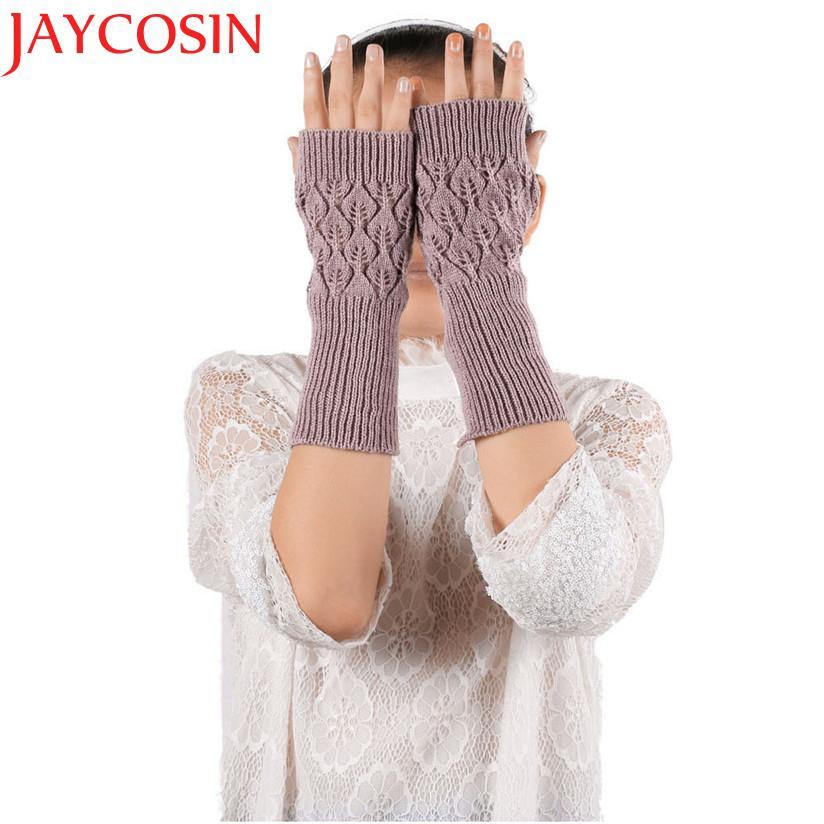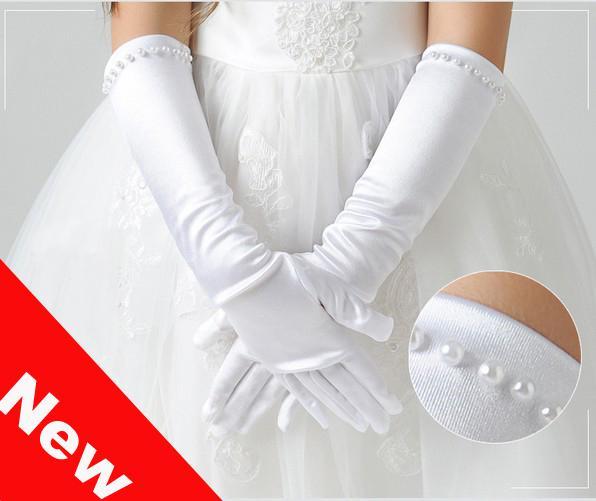The first image is the image on the left, the second image is the image on the right. Considering the images on both sides, is "A white pair of gloves is modeled on crossed hands, while a casual knit pair is modeled side by side." valid? Answer yes or no. Yes. The first image is the image on the left, the second image is the image on the right. Analyze the images presented: Is the assertion "Each image shows a pair of completely fingerless 'gloves' worn by a model, and the hands wearing gloves are posed fingers-up on the left, and fingers-down on the right." valid? Answer yes or no. No. 